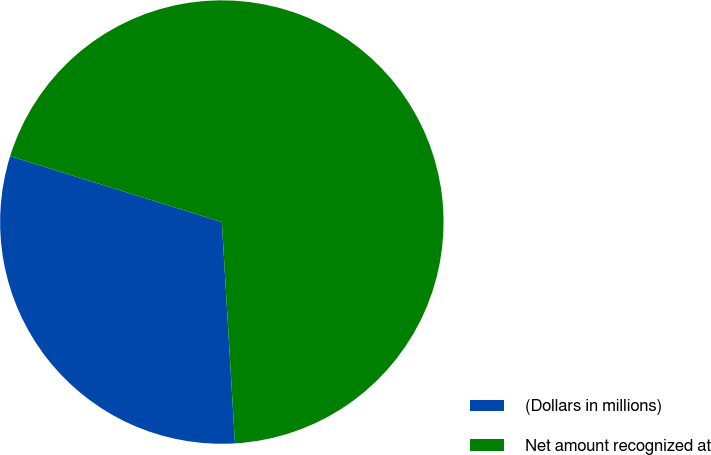Convert chart. <chart><loc_0><loc_0><loc_500><loc_500><pie_chart><fcel>(Dollars in millions)<fcel>Net amount recognized at<nl><fcel>30.75%<fcel>69.25%<nl></chart> 